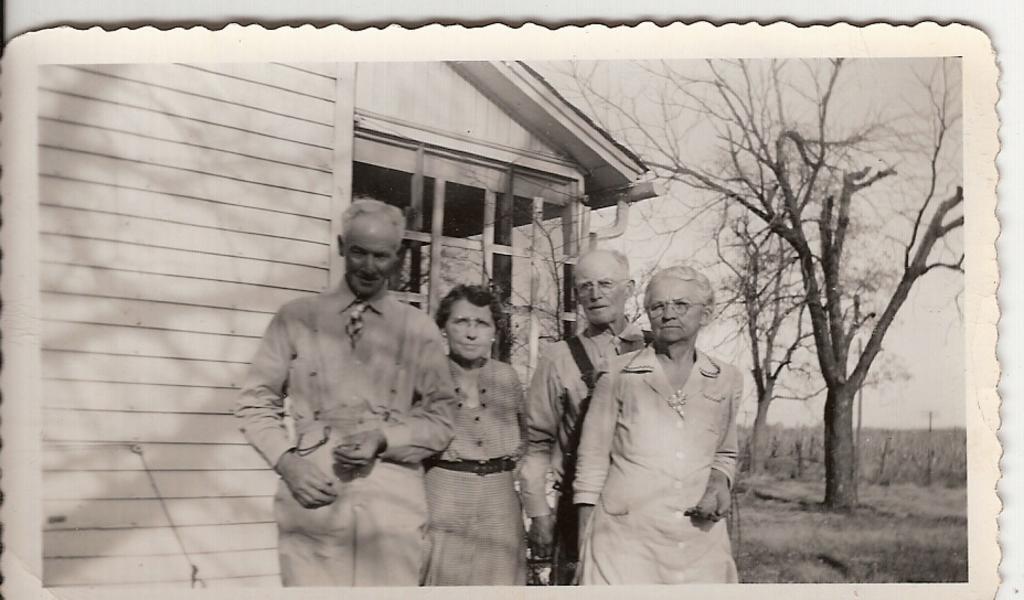Describe this image in one or two sentences. In this picture we can see a photo, in this photo there are people and we can see house, trees, grass and sky. In the background of the image it is white. 